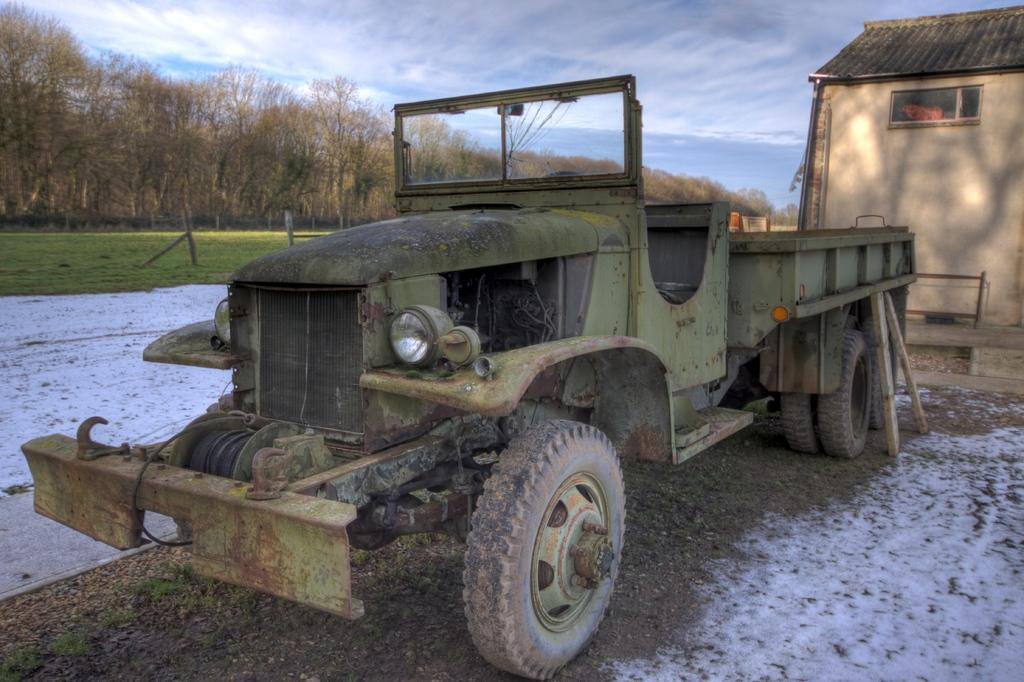In one or two sentences, can you explain what this image depicts? This picture is clicked outside. In the center there is a green color truck placed on the ground. On the left we can see the snow and the green grass. On the right there is a house and we can see the window of the house. In the background there is sky and the trees. 